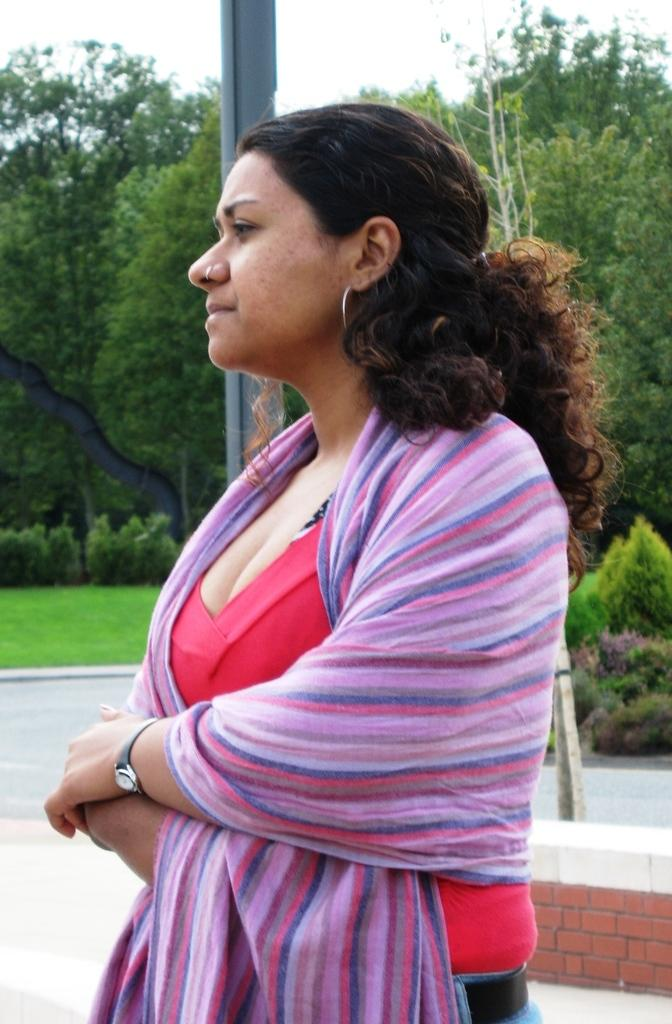What is the main subject of the image? There is a woman standing in the image. What is the woman wearing in the image? There is a scarf in the image. What type of natural environment is visible in the image? There is grass and trees in the image. What structure can be seen in the image? There is a pole in the image. What is visible in the background of the image? The sky is visible in the image. What type of farm animals can be seen grazing in the image? There is no farm or farm animals present in the image. What type of sweater is the woman wearing in the image? The woman is not wearing a sweater in the image; she is wearing a scarf. 